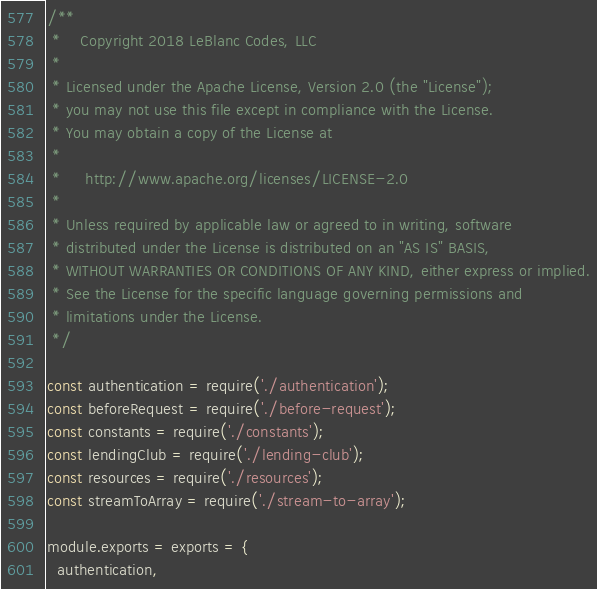Convert code to text. <code><loc_0><loc_0><loc_500><loc_500><_JavaScript_>/**
 *    Copyright 2018 LeBlanc Codes, LLC
 *
 * Licensed under the Apache License, Version 2.0 (the "License");
 * you may not use this file except in compliance with the License.
 * You may obtain a copy of the License at
 *
 *     http://www.apache.org/licenses/LICENSE-2.0
 *
 * Unless required by applicable law or agreed to in writing, software
 * distributed under the License is distributed on an "AS IS" BASIS,
 * WITHOUT WARRANTIES OR CONDITIONS OF ANY KIND, either express or implied.
 * See the License for the specific language governing permissions and
 * limitations under the License.
 */

const authentication = require('./authentication');
const beforeRequest = require('./before-request');
const constants = require('./constants');
const lendingClub = require('./lending-club');
const resources = require('./resources');
const streamToArray = require('./stream-to-array');

module.exports = exports = {
  authentication,</code> 